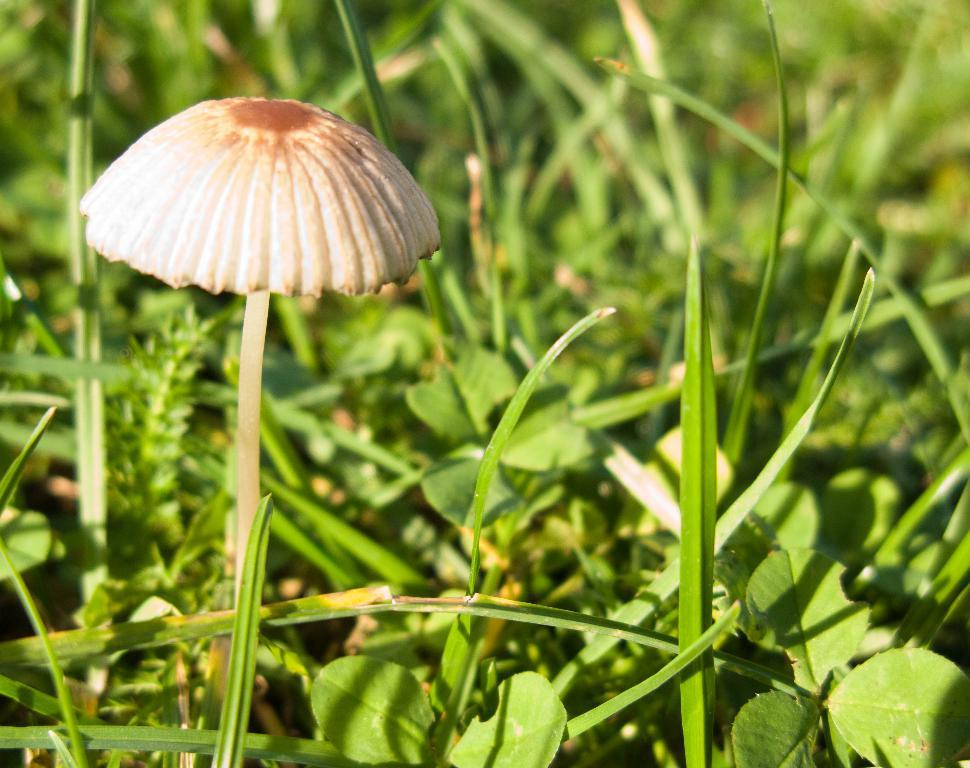What type of fungus can be seen in the image? There is a mushroom in the image. What colors are present on the mushroom? The mushroom has cream and brown colors. What type of vegetation is visible in the image? There is grass in the image. What color is the grass? The grass has a green color. What flavor of coffee is being traded in the image? There is no coffee or trading activity present in the image; it features a mushroom and grass. 